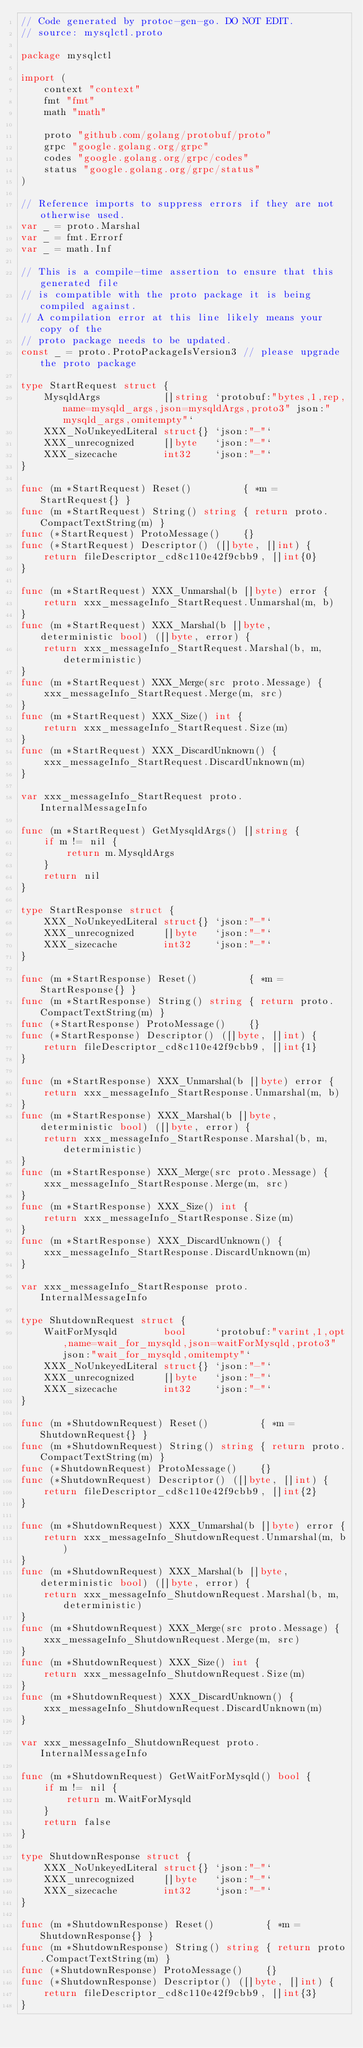Convert code to text. <code><loc_0><loc_0><loc_500><loc_500><_Go_>// Code generated by protoc-gen-go. DO NOT EDIT.
// source: mysqlctl.proto

package mysqlctl

import (
	context "context"
	fmt "fmt"
	math "math"

	proto "github.com/golang/protobuf/proto"
	grpc "google.golang.org/grpc"
	codes "google.golang.org/grpc/codes"
	status "google.golang.org/grpc/status"
)

// Reference imports to suppress errors if they are not otherwise used.
var _ = proto.Marshal
var _ = fmt.Errorf
var _ = math.Inf

// This is a compile-time assertion to ensure that this generated file
// is compatible with the proto package it is being compiled against.
// A compilation error at this line likely means your copy of the
// proto package needs to be updated.
const _ = proto.ProtoPackageIsVersion3 // please upgrade the proto package

type StartRequest struct {
	MysqldArgs           []string `protobuf:"bytes,1,rep,name=mysqld_args,json=mysqldArgs,proto3" json:"mysqld_args,omitempty"`
	XXX_NoUnkeyedLiteral struct{} `json:"-"`
	XXX_unrecognized     []byte   `json:"-"`
	XXX_sizecache        int32    `json:"-"`
}

func (m *StartRequest) Reset()         { *m = StartRequest{} }
func (m *StartRequest) String() string { return proto.CompactTextString(m) }
func (*StartRequest) ProtoMessage()    {}
func (*StartRequest) Descriptor() ([]byte, []int) {
	return fileDescriptor_cd8c110e42f9cbb9, []int{0}
}

func (m *StartRequest) XXX_Unmarshal(b []byte) error {
	return xxx_messageInfo_StartRequest.Unmarshal(m, b)
}
func (m *StartRequest) XXX_Marshal(b []byte, deterministic bool) ([]byte, error) {
	return xxx_messageInfo_StartRequest.Marshal(b, m, deterministic)
}
func (m *StartRequest) XXX_Merge(src proto.Message) {
	xxx_messageInfo_StartRequest.Merge(m, src)
}
func (m *StartRequest) XXX_Size() int {
	return xxx_messageInfo_StartRequest.Size(m)
}
func (m *StartRequest) XXX_DiscardUnknown() {
	xxx_messageInfo_StartRequest.DiscardUnknown(m)
}

var xxx_messageInfo_StartRequest proto.InternalMessageInfo

func (m *StartRequest) GetMysqldArgs() []string {
	if m != nil {
		return m.MysqldArgs
	}
	return nil
}

type StartResponse struct {
	XXX_NoUnkeyedLiteral struct{} `json:"-"`
	XXX_unrecognized     []byte   `json:"-"`
	XXX_sizecache        int32    `json:"-"`
}

func (m *StartResponse) Reset()         { *m = StartResponse{} }
func (m *StartResponse) String() string { return proto.CompactTextString(m) }
func (*StartResponse) ProtoMessage()    {}
func (*StartResponse) Descriptor() ([]byte, []int) {
	return fileDescriptor_cd8c110e42f9cbb9, []int{1}
}

func (m *StartResponse) XXX_Unmarshal(b []byte) error {
	return xxx_messageInfo_StartResponse.Unmarshal(m, b)
}
func (m *StartResponse) XXX_Marshal(b []byte, deterministic bool) ([]byte, error) {
	return xxx_messageInfo_StartResponse.Marshal(b, m, deterministic)
}
func (m *StartResponse) XXX_Merge(src proto.Message) {
	xxx_messageInfo_StartResponse.Merge(m, src)
}
func (m *StartResponse) XXX_Size() int {
	return xxx_messageInfo_StartResponse.Size(m)
}
func (m *StartResponse) XXX_DiscardUnknown() {
	xxx_messageInfo_StartResponse.DiscardUnknown(m)
}

var xxx_messageInfo_StartResponse proto.InternalMessageInfo

type ShutdownRequest struct {
	WaitForMysqld        bool     `protobuf:"varint,1,opt,name=wait_for_mysqld,json=waitForMysqld,proto3" json:"wait_for_mysqld,omitempty"`
	XXX_NoUnkeyedLiteral struct{} `json:"-"`
	XXX_unrecognized     []byte   `json:"-"`
	XXX_sizecache        int32    `json:"-"`
}

func (m *ShutdownRequest) Reset()         { *m = ShutdownRequest{} }
func (m *ShutdownRequest) String() string { return proto.CompactTextString(m) }
func (*ShutdownRequest) ProtoMessage()    {}
func (*ShutdownRequest) Descriptor() ([]byte, []int) {
	return fileDescriptor_cd8c110e42f9cbb9, []int{2}
}

func (m *ShutdownRequest) XXX_Unmarshal(b []byte) error {
	return xxx_messageInfo_ShutdownRequest.Unmarshal(m, b)
}
func (m *ShutdownRequest) XXX_Marshal(b []byte, deterministic bool) ([]byte, error) {
	return xxx_messageInfo_ShutdownRequest.Marshal(b, m, deterministic)
}
func (m *ShutdownRequest) XXX_Merge(src proto.Message) {
	xxx_messageInfo_ShutdownRequest.Merge(m, src)
}
func (m *ShutdownRequest) XXX_Size() int {
	return xxx_messageInfo_ShutdownRequest.Size(m)
}
func (m *ShutdownRequest) XXX_DiscardUnknown() {
	xxx_messageInfo_ShutdownRequest.DiscardUnknown(m)
}

var xxx_messageInfo_ShutdownRequest proto.InternalMessageInfo

func (m *ShutdownRequest) GetWaitForMysqld() bool {
	if m != nil {
		return m.WaitForMysqld
	}
	return false
}

type ShutdownResponse struct {
	XXX_NoUnkeyedLiteral struct{} `json:"-"`
	XXX_unrecognized     []byte   `json:"-"`
	XXX_sizecache        int32    `json:"-"`
}

func (m *ShutdownResponse) Reset()         { *m = ShutdownResponse{} }
func (m *ShutdownResponse) String() string { return proto.CompactTextString(m) }
func (*ShutdownResponse) ProtoMessage()    {}
func (*ShutdownResponse) Descriptor() ([]byte, []int) {
	return fileDescriptor_cd8c110e42f9cbb9, []int{3}
}
</code> 